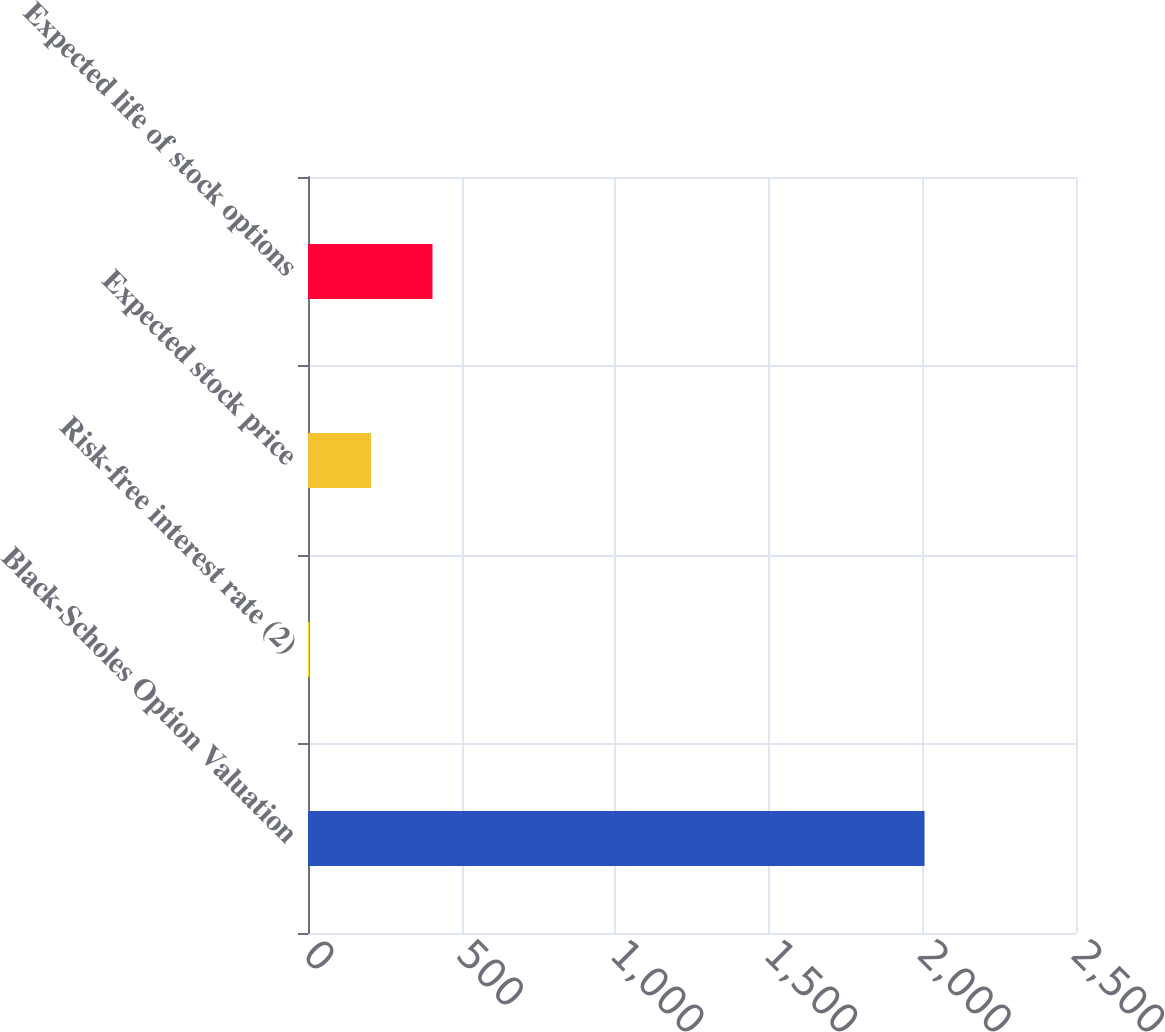Convert chart. <chart><loc_0><loc_0><loc_500><loc_500><bar_chart><fcel>Black-Scholes Option Valuation<fcel>Risk-free interest rate (2)<fcel>Expected stock price<fcel>Expected life of stock options<nl><fcel>2007<fcel>4.8<fcel>205.02<fcel>405.24<nl></chart> 